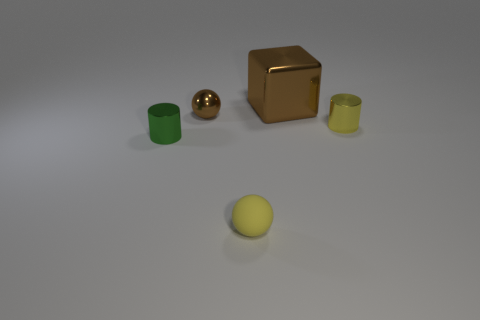Add 3 small green things. How many objects exist? 8 Subtract 0 gray cylinders. How many objects are left? 5 Subtract all cylinders. How many objects are left? 3 Subtract all large blue spheres. Subtract all yellow shiny objects. How many objects are left? 4 Add 4 big shiny things. How many big shiny things are left? 5 Add 5 small purple rubber spheres. How many small purple rubber spheres exist? 5 